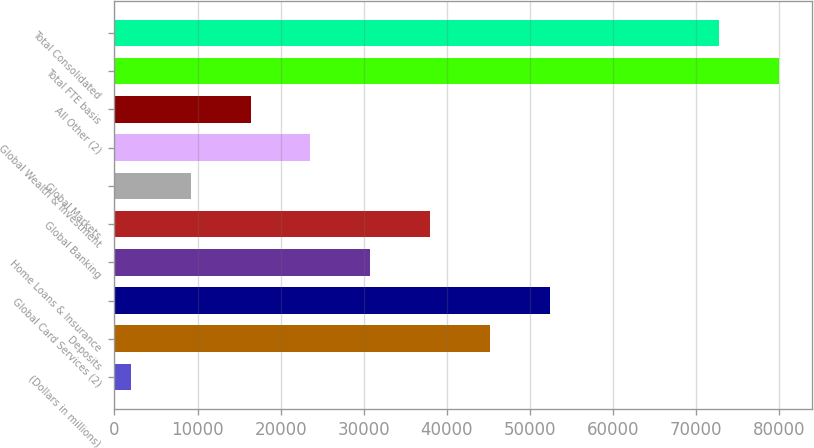<chart> <loc_0><loc_0><loc_500><loc_500><bar_chart><fcel>(Dollars in millions)<fcel>Deposits<fcel>Global Card Services (2)<fcel>Home Loans & Insurance<fcel>Global Banking<fcel>Global Markets<fcel>Global Wealth & Investment<fcel>All Other (2)<fcel>Total FTE basis<fcel>Total Consolidated<nl><fcel>2008<fcel>45188.8<fcel>52385.6<fcel>30795.2<fcel>37992<fcel>9204.8<fcel>23598.4<fcel>16401.6<fcel>79978.8<fcel>72782<nl></chart> 